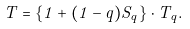<formula> <loc_0><loc_0><loc_500><loc_500>T = \{ 1 + ( 1 - q ) S _ { q } \} \cdot T _ { q } .</formula> 